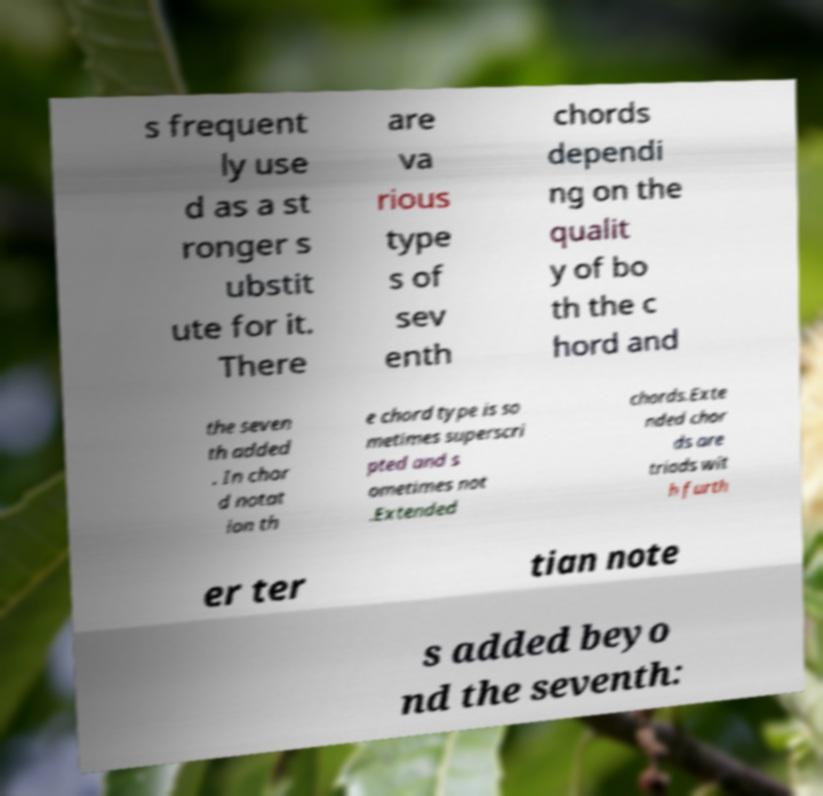What messages or text are displayed in this image? I need them in a readable, typed format. s frequent ly use d as a st ronger s ubstit ute for it. There are va rious type s of sev enth chords dependi ng on the qualit y of bo th the c hord and the seven th added . In chor d notat ion th e chord type is so metimes superscri pted and s ometimes not .Extended chords.Exte nded chor ds are triads wit h furth er ter tian note s added beyo nd the seventh: 